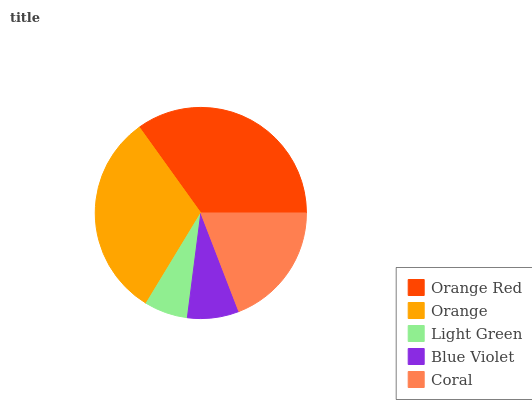Is Light Green the minimum?
Answer yes or no. Yes. Is Orange Red the maximum?
Answer yes or no. Yes. Is Orange the minimum?
Answer yes or no. No. Is Orange the maximum?
Answer yes or no. No. Is Orange Red greater than Orange?
Answer yes or no. Yes. Is Orange less than Orange Red?
Answer yes or no. Yes. Is Orange greater than Orange Red?
Answer yes or no. No. Is Orange Red less than Orange?
Answer yes or no. No. Is Coral the high median?
Answer yes or no. Yes. Is Coral the low median?
Answer yes or no. Yes. Is Orange Red the high median?
Answer yes or no. No. Is Orange the low median?
Answer yes or no. No. 